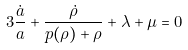Convert formula to latex. <formula><loc_0><loc_0><loc_500><loc_500>3 \frac { \dot { a } } { a } + \frac { \dot { \rho } } { p ( \rho ) + \rho } + \lambda + \mu = 0</formula> 